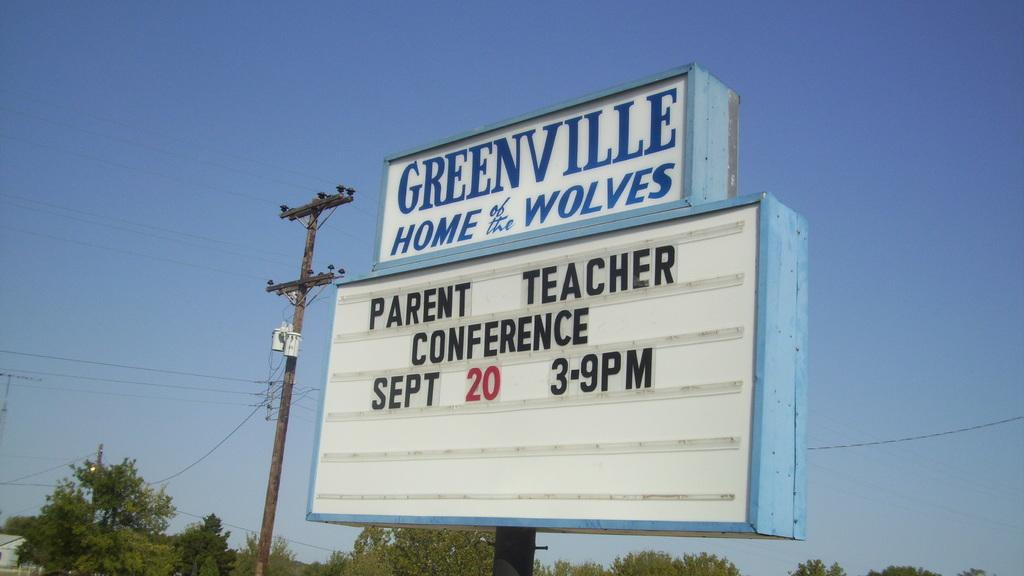<image>
Give a short and clear explanation of the subsequent image. A sign advertising parent teacher conferences on September 20 3-9 PM. 